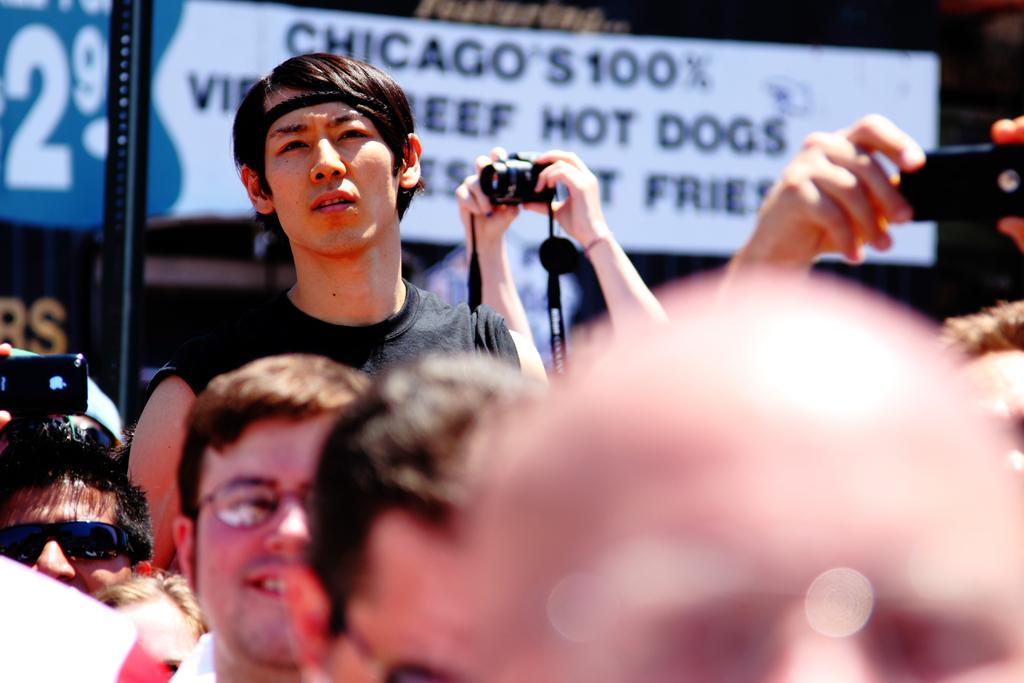How many people are in the image? There are multiple people in the image. What are some of the people holding in the image? Some of the people are holding cameras, and some are holding phones. What type of bird can be seen flying in the image? There is no bird visible in the image. What type of pancake is being served to the people in the image? There is no pancake present in the image. 